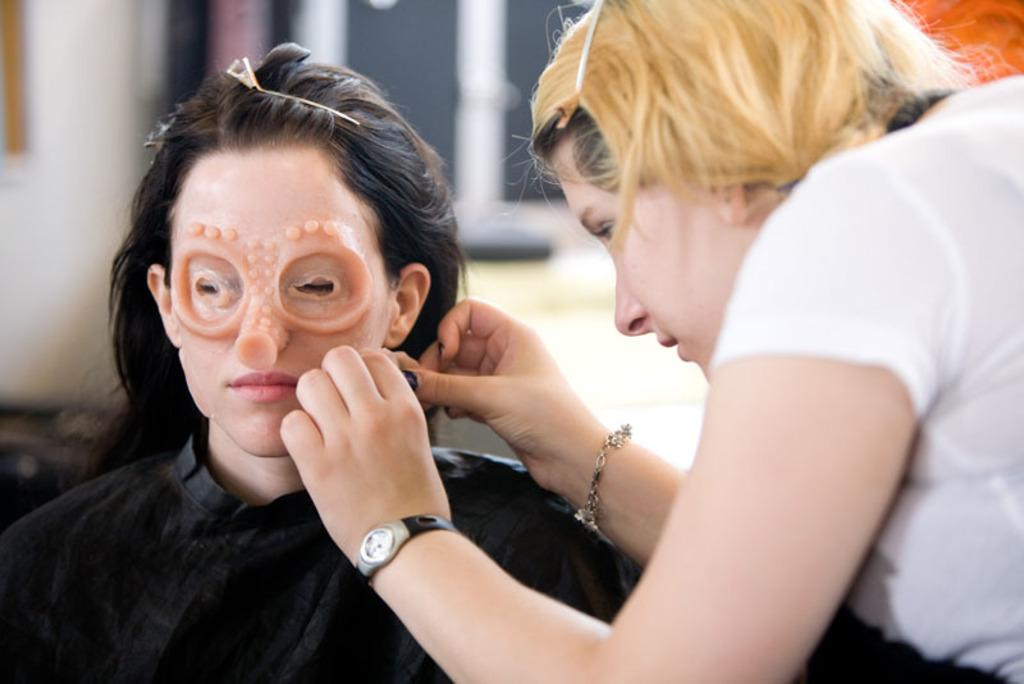What is happening on the right side of the image? There is a lady on the right side of the image, and she is removing a face mask from a person. What can be seen in the background of the image? There is a wall in the background of the image. What type of rabbit can be seen playing a game in the image? There is no rabbit or game present in the image; it features a lady removing a face mask from a person with a wall in the background. 